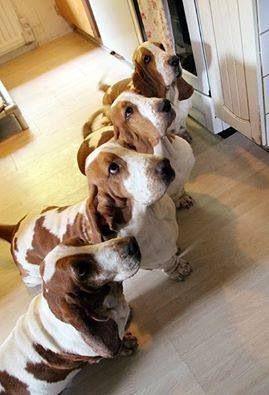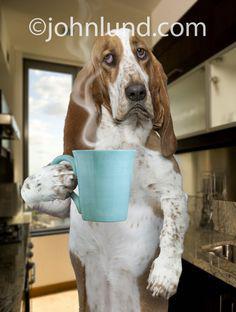The first image is the image on the left, the second image is the image on the right. For the images displayed, is the sentence "There are more than three dogs on the left, and one dog on the right." factually correct? Answer yes or no. Yes. The first image is the image on the left, the second image is the image on the right. Evaluate the accuracy of this statement regarding the images: "In one of the pictures a dog is standing on its hind legs.". Is it true? Answer yes or no. Yes. 